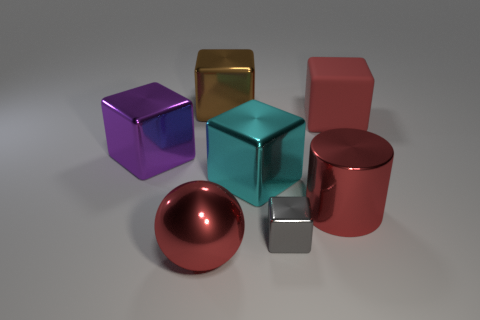Subtract all big brown blocks. How many blocks are left? 4 Add 1 tiny blue shiny spheres. How many objects exist? 8 Subtract all purple blocks. How many blocks are left? 4 Subtract all blocks. How many objects are left? 2 Subtract 1 cubes. How many cubes are left? 4 Subtract all purple cylinders. Subtract all cyan balls. How many cylinders are left? 1 Subtract all green cylinders. How many purple cubes are left? 1 Subtract all big matte objects. Subtract all big blue shiny cubes. How many objects are left? 6 Add 7 purple metallic cubes. How many purple metallic cubes are left? 8 Add 5 purple things. How many purple things exist? 6 